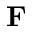<formula> <loc_0><loc_0><loc_500><loc_500>F</formula> 